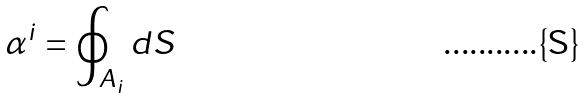Convert formula to latex. <formula><loc_0><loc_0><loc_500><loc_500>\alpha ^ { i } = \oint _ { A _ { i } } d S</formula> 